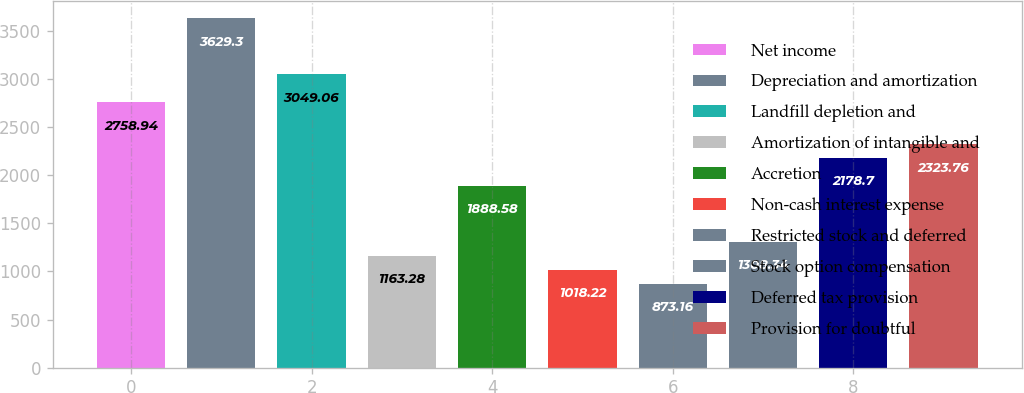Convert chart. <chart><loc_0><loc_0><loc_500><loc_500><bar_chart><fcel>Net income<fcel>Depreciation and amortization<fcel>Landfill depletion and<fcel>Amortization of intangible and<fcel>Accretion<fcel>Non-cash interest expense<fcel>Restricted stock and deferred<fcel>Stock option compensation<fcel>Deferred tax provision<fcel>Provision for doubtful<nl><fcel>2758.94<fcel>3629.3<fcel>3049.06<fcel>1163.28<fcel>1888.58<fcel>1018.22<fcel>873.16<fcel>1308.34<fcel>2178.7<fcel>2323.76<nl></chart> 